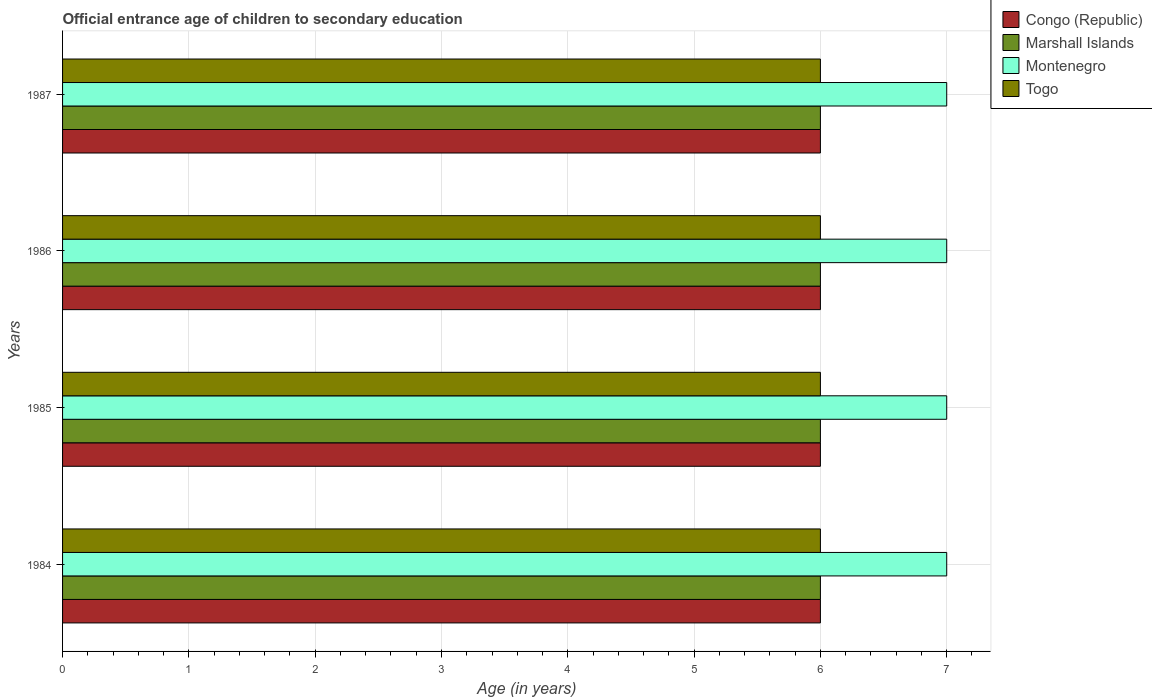How many different coloured bars are there?
Offer a very short reply. 4. Are the number of bars per tick equal to the number of legend labels?
Provide a short and direct response. Yes. How many bars are there on the 4th tick from the bottom?
Your answer should be very brief. 4. What is the label of the 4th group of bars from the top?
Give a very brief answer. 1984. Across all years, what is the maximum secondary school starting age of children in Togo?
Offer a very short reply. 6. In which year was the secondary school starting age of children in Marshall Islands maximum?
Ensure brevity in your answer.  1984. What is the total secondary school starting age of children in Marshall Islands in the graph?
Ensure brevity in your answer.  24. What is the difference between the secondary school starting age of children in Congo (Republic) in 1984 and that in 1986?
Give a very brief answer. 0. What is the difference between the secondary school starting age of children in Marshall Islands in 1985 and the secondary school starting age of children in Congo (Republic) in 1986?
Give a very brief answer. 0. In the year 1986, what is the difference between the secondary school starting age of children in Congo (Republic) and secondary school starting age of children in Togo?
Give a very brief answer. 0. What is the ratio of the secondary school starting age of children in Marshall Islands in 1984 to that in 1986?
Your answer should be compact. 1. Is the difference between the secondary school starting age of children in Congo (Republic) in 1984 and 1985 greater than the difference between the secondary school starting age of children in Togo in 1984 and 1985?
Ensure brevity in your answer.  No. What is the difference between the highest and the lowest secondary school starting age of children in Marshall Islands?
Offer a terse response. 0. In how many years, is the secondary school starting age of children in Marshall Islands greater than the average secondary school starting age of children in Marshall Islands taken over all years?
Ensure brevity in your answer.  0. Is the sum of the secondary school starting age of children in Marshall Islands in 1986 and 1987 greater than the maximum secondary school starting age of children in Togo across all years?
Offer a terse response. Yes. What does the 3rd bar from the top in 1985 represents?
Provide a succinct answer. Marshall Islands. What does the 2nd bar from the bottom in 1986 represents?
Give a very brief answer. Marshall Islands. Is it the case that in every year, the sum of the secondary school starting age of children in Montenegro and secondary school starting age of children in Marshall Islands is greater than the secondary school starting age of children in Togo?
Offer a terse response. Yes. Are all the bars in the graph horizontal?
Your response must be concise. Yes. How many years are there in the graph?
Provide a short and direct response. 4. What is the difference between two consecutive major ticks on the X-axis?
Keep it short and to the point. 1. Does the graph contain any zero values?
Offer a terse response. No. Does the graph contain grids?
Your answer should be compact. Yes. What is the title of the graph?
Provide a succinct answer. Official entrance age of children to secondary education. What is the label or title of the X-axis?
Provide a short and direct response. Age (in years). What is the label or title of the Y-axis?
Your answer should be very brief. Years. What is the Age (in years) in Marshall Islands in 1984?
Ensure brevity in your answer.  6. What is the Age (in years) in Montenegro in 1984?
Keep it short and to the point. 7. What is the Age (in years) of Togo in 1984?
Offer a very short reply. 6. What is the Age (in years) in Marshall Islands in 1986?
Make the answer very short. 6. What is the Age (in years) of Montenegro in 1986?
Keep it short and to the point. 7. What is the Age (in years) in Montenegro in 1987?
Ensure brevity in your answer.  7. Across all years, what is the maximum Age (in years) of Congo (Republic)?
Provide a succinct answer. 6. Across all years, what is the maximum Age (in years) in Marshall Islands?
Your answer should be very brief. 6. Across all years, what is the maximum Age (in years) of Togo?
Ensure brevity in your answer.  6. Across all years, what is the minimum Age (in years) in Marshall Islands?
Your answer should be compact. 6. Across all years, what is the minimum Age (in years) in Montenegro?
Ensure brevity in your answer.  7. What is the total Age (in years) of Togo in the graph?
Make the answer very short. 24. What is the difference between the Age (in years) in Congo (Republic) in 1984 and that in 1985?
Your answer should be compact. 0. What is the difference between the Age (in years) of Montenegro in 1984 and that in 1985?
Your response must be concise. 0. What is the difference between the Age (in years) of Togo in 1984 and that in 1985?
Your answer should be compact. 0. What is the difference between the Age (in years) in Congo (Republic) in 1984 and that in 1986?
Your answer should be very brief. 0. What is the difference between the Age (in years) of Marshall Islands in 1984 and that in 1986?
Offer a very short reply. 0. What is the difference between the Age (in years) in Congo (Republic) in 1984 and that in 1987?
Your answer should be very brief. 0. What is the difference between the Age (in years) of Montenegro in 1984 and that in 1987?
Give a very brief answer. 0. What is the difference between the Age (in years) of Togo in 1984 and that in 1987?
Provide a short and direct response. 0. What is the difference between the Age (in years) of Congo (Republic) in 1985 and that in 1986?
Your answer should be very brief. 0. What is the difference between the Age (in years) of Togo in 1985 and that in 1986?
Your response must be concise. 0. What is the difference between the Age (in years) in Congo (Republic) in 1985 and that in 1987?
Provide a short and direct response. 0. What is the difference between the Age (in years) of Montenegro in 1985 and that in 1987?
Provide a succinct answer. 0. What is the difference between the Age (in years) in Congo (Republic) in 1986 and that in 1987?
Make the answer very short. 0. What is the difference between the Age (in years) of Togo in 1986 and that in 1987?
Make the answer very short. 0. What is the difference between the Age (in years) of Congo (Republic) in 1984 and the Age (in years) of Marshall Islands in 1985?
Provide a short and direct response. 0. What is the difference between the Age (in years) of Marshall Islands in 1984 and the Age (in years) of Montenegro in 1985?
Provide a short and direct response. -1. What is the difference between the Age (in years) in Congo (Republic) in 1984 and the Age (in years) in Marshall Islands in 1986?
Your answer should be compact. 0. What is the difference between the Age (in years) in Marshall Islands in 1984 and the Age (in years) in Montenegro in 1986?
Make the answer very short. -1. What is the difference between the Age (in years) in Congo (Republic) in 1984 and the Age (in years) in Marshall Islands in 1987?
Ensure brevity in your answer.  0. What is the difference between the Age (in years) of Congo (Republic) in 1984 and the Age (in years) of Montenegro in 1987?
Give a very brief answer. -1. What is the difference between the Age (in years) in Congo (Republic) in 1985 and the Age (in years) in Marshall Islands in 1986?
Ensure brevity in your answer.  0. What is the difference between the Age (in years) in Congo (Republic) in 1985 and the Age (in years) in Togo in 1986?
Your answer should be very brief. 0. What is the difference between the Age (in years) in Marshall Islands in 1985 and the Age (in years) in Montenegro in 1986?
Keep it short and to the point. -1. What is the difference between the Age (in years) of Marshall Islands in 1985 and the Age (in years) of Togo in 1986?
Ensure brevity in your answer.  0. What is the difference between the Age (in years) of Montenegro in 1985 and the Age (in years) of Togo in 1986?
Make the answer very short. 1. What is the difference between the Age (in years) in Congo (Republic) in 1985 and the Age (in years) in Marshall Islands in 1987?
Ensure brevity in your answer.  0. What is the difference between the Age (in years) in Marshall Islands in 1985 and the Age (in years) in Montenegro in 1987?
Your answer should be very brief. -1. What is the difference between the Age (in years) in Montenegro in 1985 and the Age (in years) in Togo in 1987?
Provide a succinct answer. 1. What is the difference between the Age (in years) in Congo (Republic) in 1986 and the Age (in years) in Montenegro in 1987?
Your answer should be very brief. -1. What is the difference between the Age (in years) of Montenegro in 1986 and the Age (in years) of Togo in 1987?
Give a very brief answer. 1. What is the average Age (in years) of Congo (Republic) per year?
Provide a succinct answer. 6. What is the average Age (in years) of Marshall Islands per year?
Provide a short and direct response. 6. What is the average Age (in years) of Montenegro per year?
Make the answer very short. 7. In the year 1984, what is the difference between the Age (in years) in Congo (Republic) and Age (in years) in Montenegro?
Give a very brief answer. -1. In the year 1984, what is the difference between the Age (in years) in Marshall Islands and Age (in years) in Montenegro?
Your response must be concise. -1. In the year 1984, what is the difference between the Age (in years) in Marshall Islands and Age (in years) in Togo?
Offer a very short reply. 0. In the year 1985, what is the difference between the Age (in years) in Congo (Republic) and Age (in years) in Montenegro?
Provide a short and direct response. -1. In the year 1985, what is the difference between the Age (in years) in Congo (Republic) and Age (in years) in Togo?
Give a very brief answer. 0. In the year 1985, what is the difference between the Age (in years) of Marshall Islands and Age (in years) of Montenegro?
Provide a succinct answer. -1. In the year 1986, what is the difference between the Age (in years) of Congo (Republic) and Age (in years) of Marshall Islands?
Make the answer very short. 0. In the year 1986, what is the difference between the Age (in years) in Congo (Republic) and Age (in years) in Togo?
Your answer should be compact. 0. In the year 1986, what is the difference between the Age (in years) in Marshall Islands and Age (in years) in Montenegro?
Provide a short and direct response. -1. In the year 1986, what is the difference between the Age (in years) of Montenegro and Age (in years) of Togo?
Provide a succinct answer. 1. In the year 1987, what is the difference between the Age (in years) of Congo (Republic) and Age (in years) of Montenegro?
Keep it short and to the point. -1. In the year 1987, what is the difference between the Age (in years) of Congo (Republic) and Age (in years) of Togo?
Offer a terse response. 0. In the year 1987, what is the difference between the Age (in years) of Marshall Islands and Age (in years) of Togo?
Your response must be concise. 0. What is the ratio of the Age (in years) of Montenegro in 1984 to that in 1985?
Make the answer very short. 1. What is the ratio of the Age (in years) of Congo (Republic) in 1984 to that in 1986?
Ensure brevity in your answer.  1. What is the ratio of the Age (in years) in Montenegro in 1984 to that in 1986?
Your response must be concise. 1. What is the ratio of the Age (in years) of Congo (Republic) in 1985 to that in 1986?
Ensure brevity in your answer.  1. What is the ratio of the Age (in years) in Montenegro in 1985 to that in 1986?
Offer a very short reply. 1. What is the ratio of the Age (in years) of Marshall Islands in 1985 to that in 1987?
Provide a succinct answer. 1. What is the ratio of the Age (in years) in Montenegro in 1985 to that in 1987?
Your response must be concise. 1. What is the ratio of the Age (in years) in Togo in 1985 to that in 1987?
Your response must be concise. 1. What is the ratio of the Age (in years) of Congo (Republic) in 1986 to that in 1987?
Offer a terse response. 1. What is the ratio of the Age (in years) in Montenegro in 1986 to that in 1987?
Your response must be concise. 1. What is the difference between the highest and the second highest Age (in years) in Congo (Republic)?
Your answer should be very brief. 0. What is the difference between the highest and the second highest Age (in years) of Marshall Islands?
Your answer should be compact. 0. What is the difference between the highest and the second highest Age (in years) in Montenegro?
Keep it short and to the point. 0. What is the difference between the highest and the second highest Age (in years) of Togo?
Provide a short and direct response. 0. What is the difference between the highest and the lowest Age (in years) in Togo?
Make the answer very short. 0. 